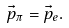Convert formula to latex. <formula><loc_0><loc_0><loc_500><loc_500>\vec { p } _ { \pi } = \vec { p } _ { e } .</formula> 